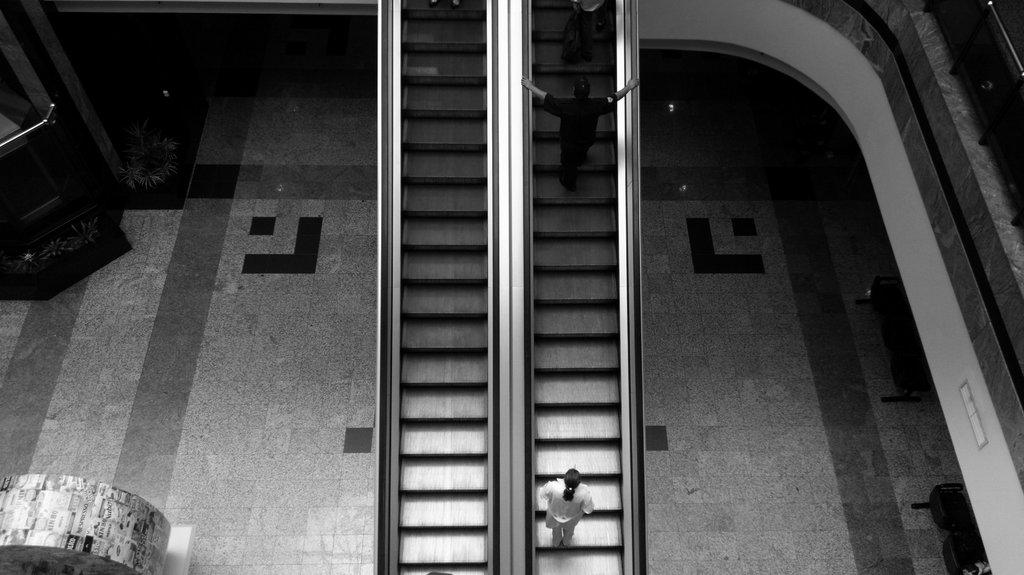What is the main subject in the middle of the image? There is an escalator in the middle of the image. What are people doing in relation to the escalator? People are using the escalator. What type of crown can be seen on the sun in the image? There is no sun or crown present in the image; it features an escalator and people using it. 